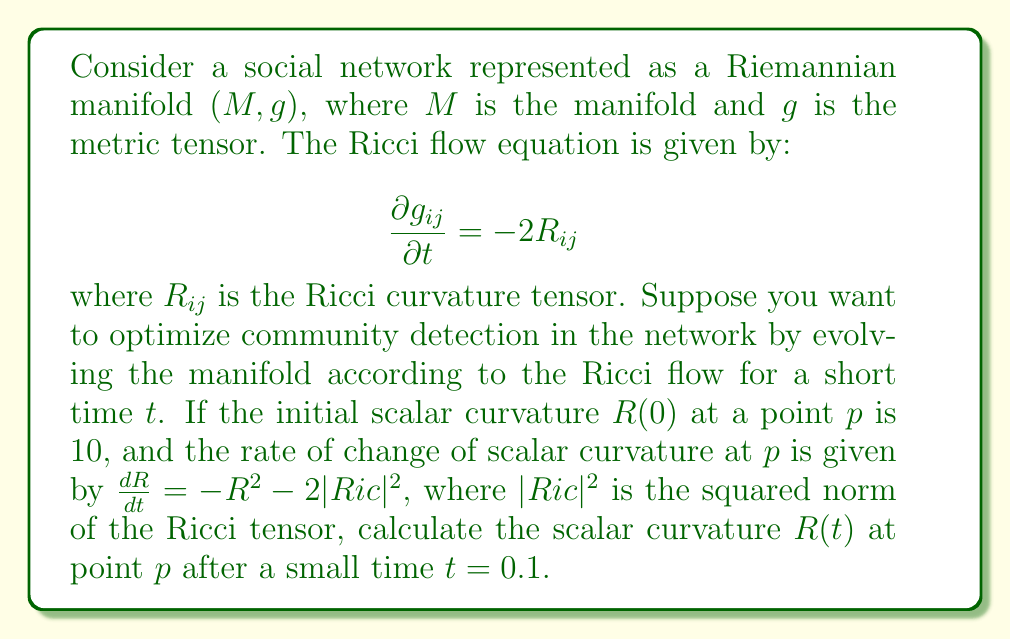Could you help me with this problem? To solve this problem, we need to use the given information and the properties of Ricci flow. Let's break it down step by step:

1) We are given the initial scalar curvature $R(0) = 10$ at point $p$.

2) The rate of change of scalar curvature is given by:

   $$\frac{dR}{dt} = -R^2 - 2|Ric|^2$$

3) We need to find $R(t)$ at $t = 0.1$. For small $t$, we can use a first-order approximation:

   $$R(t) \approx R(0) + t\frac{dR}{dt}|_{t=0}$$

4) To use this approximation, we need to calculate $\frac{dR}{dt}|_{t=0}$. For this, we need to know $|Ric|^2$ at $t=0$.

5) In general, $|Ric|^2 \geq \frac{1}{n}R^2$, where $n$ is the dimension of the manifold. The equality holds for Einstein manifolds. For a social network, we can assume a high-dimensional space, so let's approximate $|Ric|^2 \approx \frac{1}{n}R^2$ with $n$ large.

6) Substituting this into our equation:

   $$\frac{dR}{dt} = -R^2 - 2(\frac{1}{n}R^2) = -(1+\frac{2}{n})R^2$$

7) At $t=0$, $R=10$, so:

   $$\frac{dR}{dt}|_{t=0} = -(1+\frac{2}{n})100$$

8) For large $n$, $1+\frac{2}{n} \approx 1$, so:

   $$\frac{dR}{dt}|_{t=0} \approx -100$$

9) Now we can use our approximation:

   $$R(0.1) \approx R(0) + 0.1\frac{dR}{dt}|_{t=0} = 10 + 0.1(-100) = 10 - 10 = 0$$

Therefore, after a small time $t=0.1$, the scalar curvature at point $p$ is approximately 0.
Answer: $R(0.1) \approx 0$ 